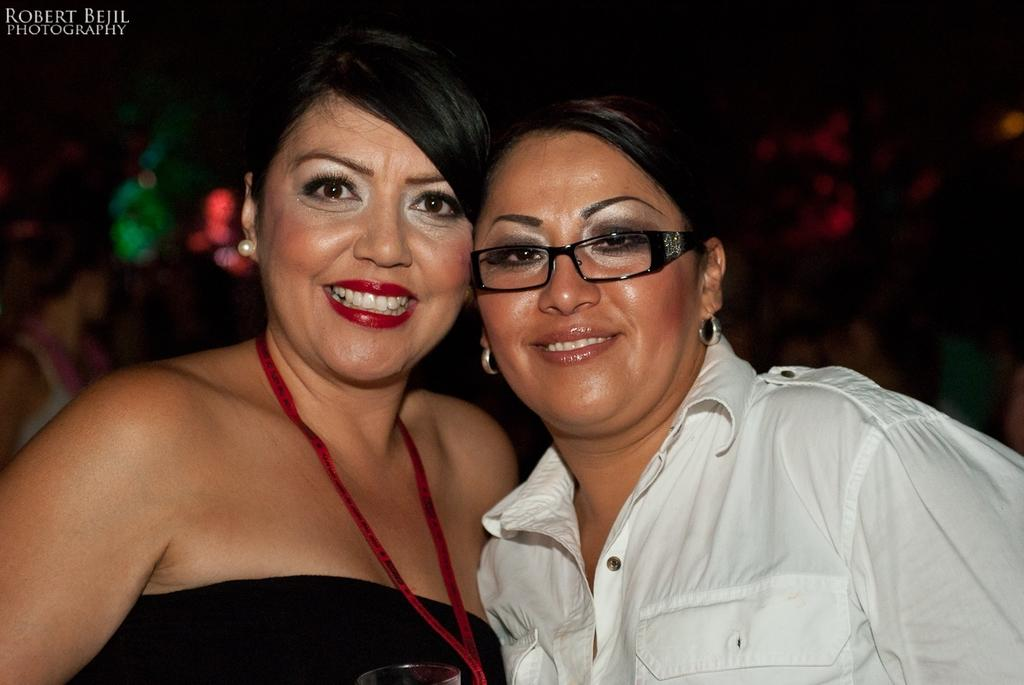What is the main subject of the image? The main subject of the image is people. How many people are in the image? There are people in the center of the image. What are the people doing in the image? The people are smiling. Can you describe any specific features of one of the people? One of the people is wearing glasses. What type of whistle can be heard in the image? There is no whistle present in the image, and therefore no sound can be heard. 